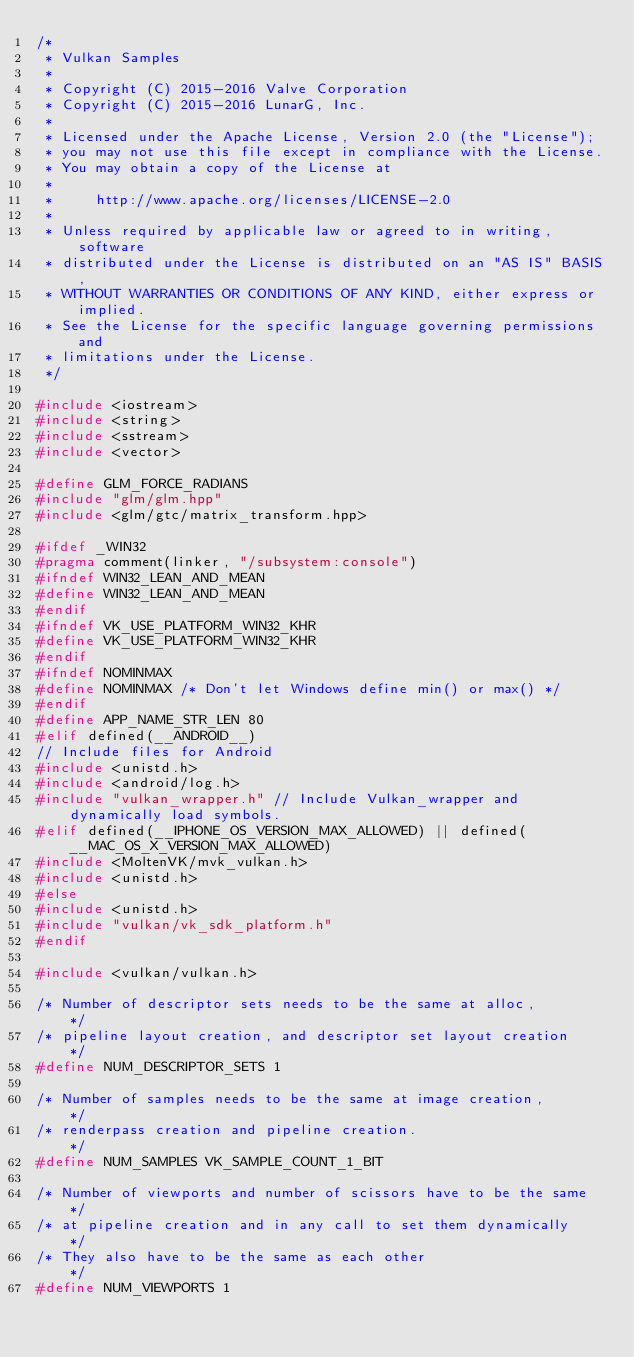Convert code to text. <code><loc_0><loc_0><loc_500><loc_500><_C++_>/*
 * Vulkan Samples
 *
 * Copyright (C) 2015-2016 Valve Corporation
 * Copyright (C) 2015-2016 LunarG, Inc.
 *
 * Licensed under the Apache License, Version 2.0 (the "License");
 * you may not use this file except in compliance with the License.
 * You may obtain a copy of the License at
 *
 *     http://www.apache.org/licenses/LICENSE-2.0
 *
 * Unless required by applicable law or agreed to in writing, software
 * distributed under the License is distributed on an "AS IS" BASIS,
 * WITHOUT WARRANTIES OR CONDITIONS OF ANY KIND, either express or implied.
 * See the License for the specific language governing permissions and
 * limitations under the License.
 */

#include <iostream>
#include <string>
#include <sstream>
#include <vector>

#define GLM_FORCE_RADIANS
#include "glm/glm.hpp"
#include <glm/gtc/matrix_transform.hpp>

#ifdef _WIN32
#pragma comment(linker, "/subsystem:console")
#ifndef WIN32_LEAN_AND_MEAN
#define WIN32_LEAN_AND_MEAN
#endif
#ifndef VK_USE_PLATFORM_WIN32_KHR
#define VK_USE_PLATFORM_WIN32_KHR
#endif
#ifndef NOMINMAX
#define NOMINMAX /* Don't let Windows define min() or max() */
#endif
#define APP_NAME_STR_LEN 80
#elif defined(__ANDROID__)
// Include files for Android
#include <unistd.h>
#include <android/log.h>
#include "vulkan_wrapper.h" // Include Vulkan_wrapper and dynamically load symbols.
#elif defined(__IPHONE_OS_VERSION_MAX_ALLOWED) || defined(__MAC_OS_X_VERSION_MAX_ALLOWED)
#include <MoltenVK/mvk_vulkan.h>
#include <unistd.h>
#else
#include <unistd.h>
#include "vulkan/vk_sdk_platform.h"
#endif

#include <vulkan/vulkan.h>

/* Number of descriptor sets needs to be the same at alloc,       */
/* pipeline layout creation, and descriptor set layout creation   */
#define NUM_DESCRIPTOR_SETS 1

/* Number of samples needs to be the same at image creation,      */
/* renderpass creation and pipeline creation.                     */
#define NUM_SAMPLES VK_SAMPLE_COUNT_1_BIT

/* Number of viewports and number of scissors have to be the same */
/* at pipeline creation and in any call to set them dynamically   */
/* They also have to be the same as each other                    */
#define NUM_VIEWPORTS 1</code> 